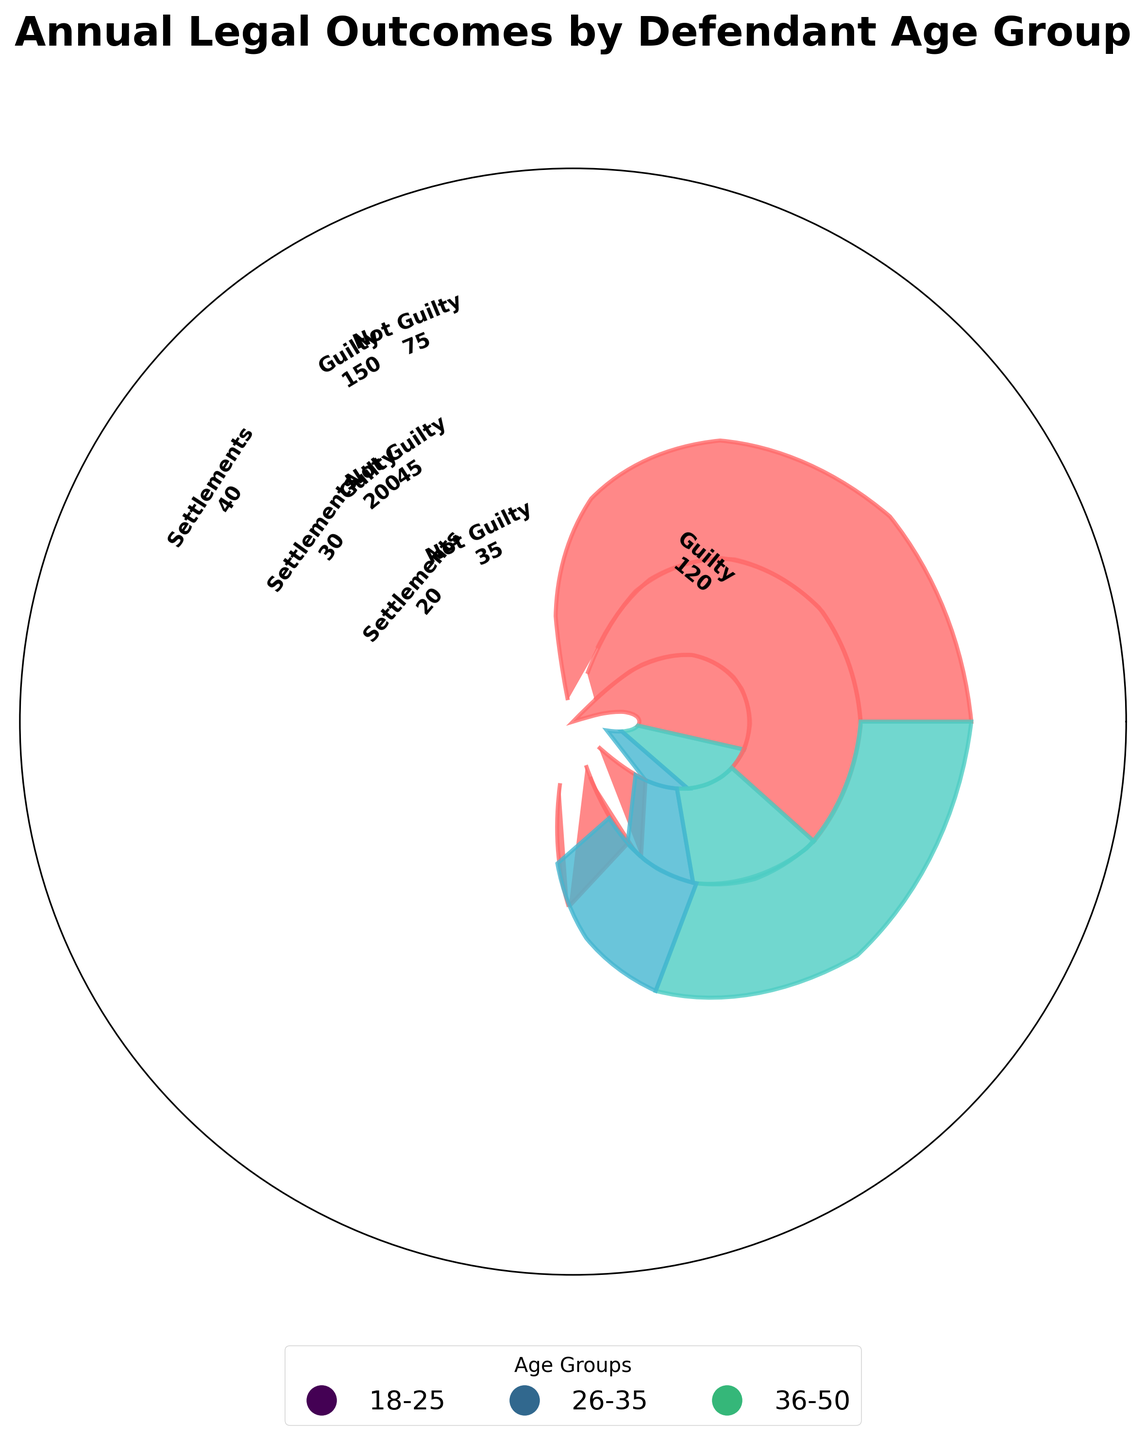What is the title of the figure? The title is displayed at the top of the chart. It should be clearly visible and readable.
Answer: Annual Legal Outcomes by Defendant Age Group Which age group has the highest number of Guilty outcomes? Look for the age group with the largest segment labeled "Guilty" in the chart. The size of the Guilty segment indicates the number of outcomes.
Answer: 26-35 How many segments are there for the age group 36-50? Observe the segments within the radial space dedicated to the age group 36-50. Each distinct colored segment represents an outcome.
Answer: 3 What is the total number of Settlements for the age group 18-25? Identify the segment for Settlements within the age group 18-25. The segment's label indicates the number of Settlements.
Answer: 50 Which age group has more Not Guilty outcomes: 18-25 or 36-50? Check the segments labeled "Not Guilty" for both age groups. Compare the numbers to determine which is larger.
Answer: 36-50 What is the average number of Not Guilty outcomes across all age groups? Sum the Not Guilty outcomes for all age groups (110 + 150 + 125) and divide by the number of age groups (3).
Answer: 128.33 Do the Settlements numbers for age group 26-35 exceed the total outcomes for the age group 18-25 in any single category? Compare the total Settlements of 80 for age group 26-35 with each category's total outcomes in the age group 18-25 (Guilty, Not Guilty, Settlements). Ensure you're comparing Settlement values to each category's sub-total.
Answer: No Which legal outcome appears least frequently for the age group 36-50? Look at each labeled segment for the age group 36-50. Identify the smallest value among Guilty, Not Guilty, and Settlements.
Answer: Settlements How does the number of Guilty outcomes for age group 18-25 compare to the number of Settlements for age group 26-35? Compare the Guilty number (120 for 18-25) with Settlements (80 for 26-35) directly.
Answer: Guilty outcomes for 18-25 are higher Which legal outcome is significantly larger for age group 26-35 compared to 18-25? Check the segments for each outcome (Guilty, Not Guilty, Settlements) in both age groups. Identify which outcome's difference is notably larger.
Answer: Guilty 